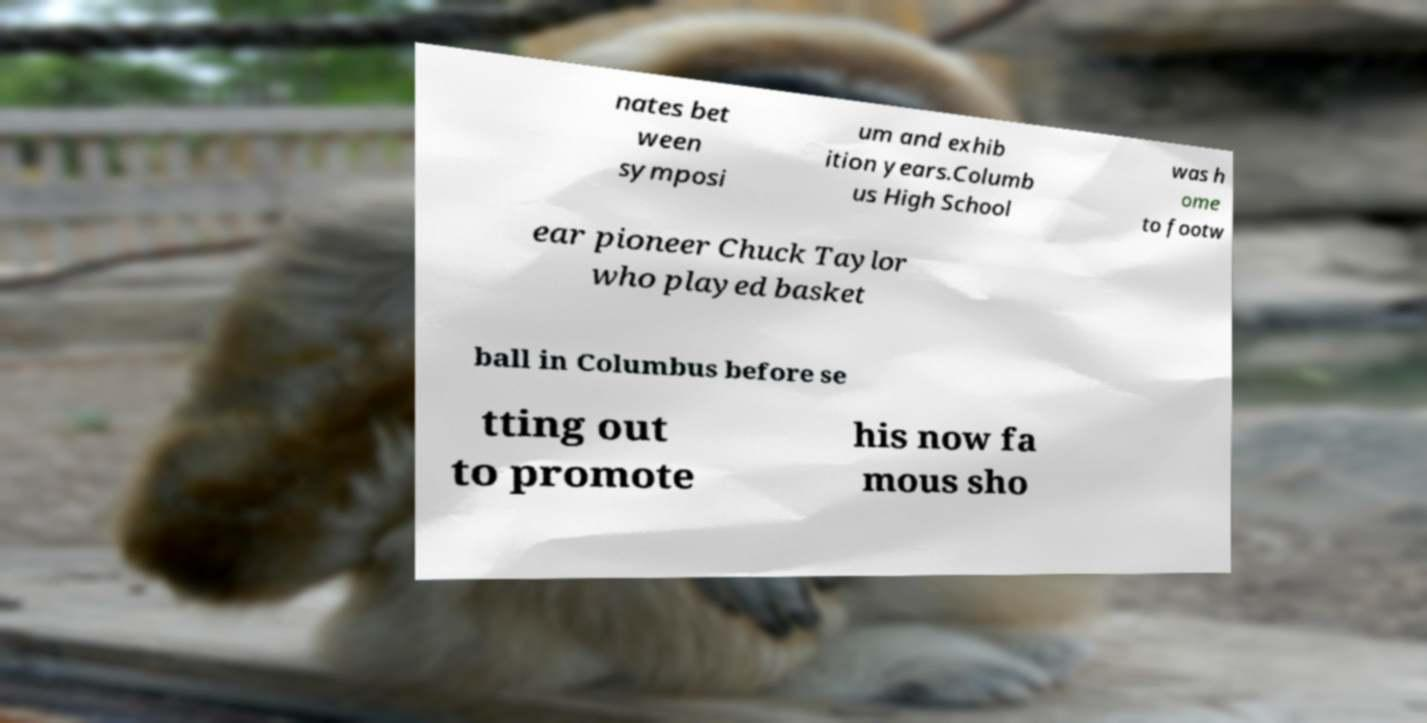Could you assist in decoding the text presented in this image and type it out clearly? nates bet ween symposi um and exhib ition years.Columb us High School was h ome to footw ear pioneer Chuck Taylor who played basket ball in Columbus before se tting out to promote his now fa mous sho 